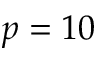Convert formula to latex. <formula><loc_0><loc_0><loc_500><loc_500>p = 1 0</formula> 